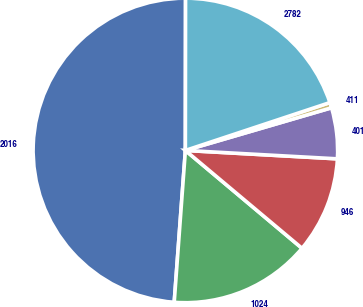<chart> <loc_0><loc_0><loc_500><loc_500><pie_chart><fcel>2016<fcel>1024<fcel>946<fcel>401<fcel>411<fcel>2782<nl><fcel>48.85%<fcel>15.06%<fcel>10.23%<fcel>5.4%<fcel>0.57%<fcel>19.89%<nl></chart> 